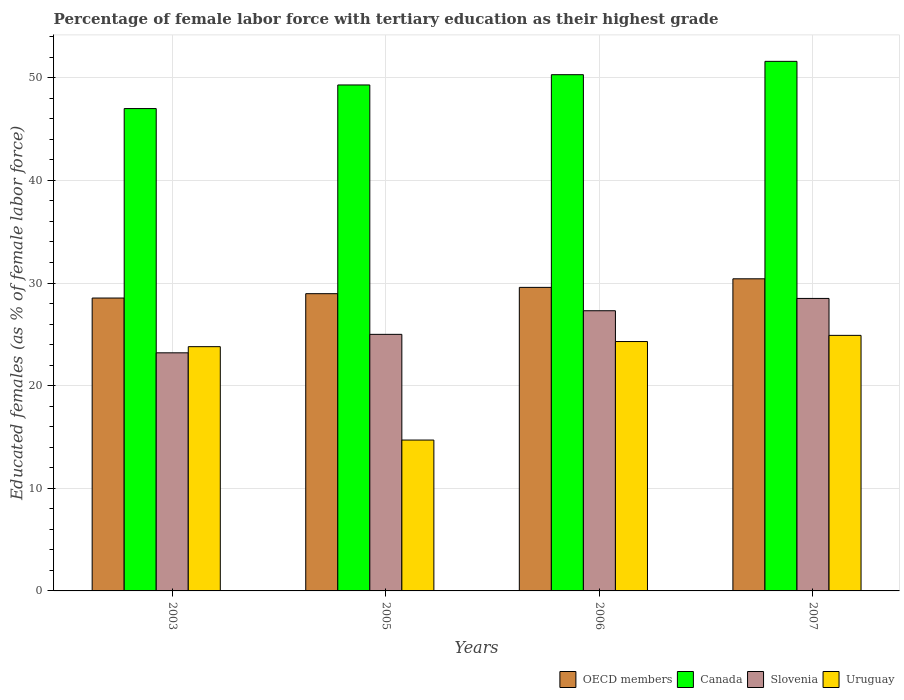How many groups of bars are there?
Provide a short and direct response. 4. Are the number of bars on each tick of the X-axis equal?
Keep it short and to the point. Yes. How many bars are there on the 2nd tick from the right?
Make the answer very short. 4. What is the label of the 1st group of bars from the left?
Provide a short and direct response. 2003. In how many cases, is the number of bars for a given year not equal to the number of legend labels?
Offer a terse response. 0. What is the percentage of female labor force with tertiary education in Uruguay in 2003?
Your answer should be very brief. 23.8. Across all years, what is the maximum percentage of female labor force with tertiary education in OECD members?
Provide a short and direct response. 30.41. Across all years, what is the minimum percentage of female labor force with tertiary education in Slovenia?
Provide a succinct answer. 23.2. In which year was the percentage of female labor force with tertiary education in Canada maximum?
Make the answer very short. 2007. What is the total percentage of female labor force with tertiary education in OECD members in the graph?
Your response must be concise. 117.49. What is the difference between the percentage of female labor force with tertiary education in Slovenia in 2003 and that in 2005?
Provide a short and direct response. -1.8. What is the difference between the percentage of female labor force with tertiary education in OECD members in 2007 and the percentage of female labor force with tertiary education in Slovenia in 2005?
Ensure brevity in your answer.  5.41. What is the average percentage of female labor force with tertiary education in Canada per year?
Offer a terse response. 49.55. In the year 2007, what is the difference between the percentage of female labor force with tertiary education in Uruguay and percentage of female labor force with tertiary education in Slovenia?
Your answer should be compact. -3.6. In how many years, is the percentage of female labor force with tertiary education in Canada greater than 10 %?
Provide a short and direct response. 4. What is the ratio of the percentage of female labor force with tertiary education in Slovenia in 2003 to that in 2007?
Your answer should be very brief. 0.81. Is the percentage of female labor force with tertiary education in Slovenia in 2003 less than that in 2005?
Offer a terse response. Yes. Is the difference between the percentage of female labor force with tertiary education in Uruguay in 2005 and 2007 greater than the difference between the percentage of female labor force with tertiary education in Slovenia in 2005 and 2007?
Provide a short and direct response. No. What is the difference between the highest and the second highest percentage of female labor force with tertiary education in OECD members?
Offer a terse response. 0.84. What is the difference between the highest and the lowest percentage of female labor force with tertiary education in OECD members?
Make the answer very short. 1.87. In how many years, is the percentage of female labor force with tertiary education in Uruguay greater than the average percentage of female labor force with tertiary education in Uruguay taken over all years?
Ensure brevity in your answer.  3. Is the sum of the percentage of female labor force with tertiary education in Uruguay in 2003 and 2007 greater than the maximum percentage of female labor force with tertiary education in Slovenia across all years?
Keep it short and to the point. Yes. Is it the case that in every year, the sum of the percentage of female labor force with tertiary education in Uruguay and percentage of female labor force with tertiary education in Canada is greater than the sum of percentage of female labor force with tertiary education in OECD members and percentage of female labor force with tertiary education in Slovenia?
Your answer should be very brief. Yes. What does the 2nd bar from the right in 2006 represents?
Provide a short and direct response. Slovenia. How many bars are there?
Give a very brief answer. 16. Are all the bars in the graph horizontal?
Ensure brevity in your answer.  No. How many years are there in the graph?
Give a very brief answer. 4. What is the difference between two consecutive major ticks on the Y-axis?
Provide a succinct answer. 10. Does the graph contain any zero values?
Provide a short and direct response. No. Where does the legend appear in the graph?
Offer a very short reply. Bottom right. How many legend labels are there?
Offer a terse response. 4. What is the title of the graph?
Provide a succinct answer. Percentage of female labor force with tertiary education as their highest grade. Does "Other small states" appear as one of the legend labels in the graph?
Offer a terse response. No. What is the label or title of the X-axis?
Keep it short and to the point. Years. What is the label or title of the Y-axis?
Provide a succinct answer. Educated females (as % of female labor force). What is the Educated females (as % of female labor force) in OECD members in 2003?
Your response must be concise. 28.54. What is the Educated females (as % of female labor force) in Canada in 2003?
Offer a terse response. 47. What is the Educated females (as % of female labor force) of Slovenia in 2003?
Offer a terse response. 23.2. What is the Educated females (as % of female labor force) in Uruguay in 2003?
Ensure brevity in your answer.  23.8. What is the Educated females (as % of female labor force) of OECD members in 2005?
Your answer should be compact. 28.96. What is the Educated females (as % of female labor force) in Canada in 2005?
Provide a succinct answer. 49.3. What is the Educated females (as % of female labor force) in Slovenia in 2005?
Give a very brief answer. 25. What is the Educated females (as % of female labor force) of Uruguay in 2005?
Make the answer very short. 14.7. What is the Educated females (as % of female labor force) of OECD members in 2006?
Your response must be concise. 29.58. What is the Educated females (as % of female labor force) in Canada in 2006?
Make the answer very short. 50.3. What is the Educated females (as % of female labor force) in Slovenia in 2006?
Your answer should be compact. 27.3. What is the Educated females (as % of female labor force) in Uruguay in 2006?
Provide a succinct answer. 24.3. What is the Educated females (as % of female labor force) in OECD members in 2007?
Ensure brevity in your answer.  30.41. What is the Educated females (as % of female labor force) of Canada in 2007?
Give a very brief answer. 51.6. What is the Educated females (as % of female labor force) in Uruguay in 2007?
Provide a short and direct response. 24.9. Across all years, what is the maximum Educated females (as % of female labor force) of OECD members?
Your answer should be compact. 30.41. Across all years, what is the maximum Educated females (as % of female labor force) in Canada?
Provide a succinct answer. 51.6. Across all years, what is the maximum Educated females (as % of female labor force) of Slovenia?
Offer a very short reply. 28.5. Across all years, what is the maximum Educated females (as % of female labor force) in Uruguay?
Give a very brief answer. 24.9. Across all years, what is the minimum Educated females (as % of female labor force) of OECD members?
Give a very brief answer. 28.54. Across all years, what is the minimum Educated females (as % of female labor force) of Canada?
Offer a very short reply. 47. Across all years, what is the minimum Educated females (as % of female labor force) of Slovenia?
Make the answer very short. 23.2. Across all years, what is the minimum Educated females (as % of female labor force) in Uruguay?
Your answer should be very brief. 14.7. What is the total Educated females (as % of female labor force) in OECD members in the graph?
Give a very brief answer. 117.49. What is the total Educated females (as % of female labor force) in Canada in the graph?
Make the answer very short. 198.2. What is the total Educated females (as % of female labor force) of Slovenia in the graph?
Make the answer very short. 104. What is the total Educated females (as % of female labor force) in Uruguay in the graph?
Provide a short and direct response. 87.7. What is the difference between the Educated females (as % of female labor force) of OECD members in 2003 and that in 2005?
Provide a short and direct response. -0.42. What is the difference between the Educated females (as % of female labor force) in Canada in 2003 and that in 2005?
Make the answer very short. -2.3. What is the difference between the Educated females (as % of female labor force) of Slovenia in 2003 and that in 2005?
Keep it short and to the point. -1.8. What is the difference between the Educated females (as % of female labor force) of OECD members in 2003 and that in 2006?
Your answer should be compact. -1.04. What is the difference between the Educated females (as % of female labor force) in Canada in 2003 and that in 2006?
Give a very brief answer. -3.3. What is the difference between the Educated females (as % of female labor force) of Uruguay in 2003 and that in 2006?
Your answer should be very brief. -0.5. What is the difference between the Educated females (as % of female labor force) in OECD members in 2003 and that in 2007?
Provide a short and direct response. -1.87. What is the difference between the Educated females (as % of female labor force) in Canada in 2003 and that in 2007?
Offer a very short reply. -4.6. What is the difference between the Educated females (as % of female labor force) of OECD members in 2005 and that in 2006?
Provide a succinct answer. -0.61. What is the difference between the Educated females (as % of female labor force) in Canada in 2005 and that in 2006?
Your response must be concise. -1. What is the difference between the Educated females (as % of female labor force) in Slovenia in 2005 and that in 2006?
Keep it short and to the point. -2.3. What is the difference between the Educated females (as % of female labor force) of OECD members in 2005 and that in 2007?
Provide a succinct answer. -1.45. What is the difference between the Educated females (as % of female labor force) in Canada in 2005 and that in 2007?
Provide a succinct answer. -2.3. What is the difference between the Educated females (as % of female labor force) of Slovenia in 2005 and that in 2007?
Your answer should be very brief. -3.5. What is the difference between the Educated females (as % of female labor force) of OECD members in 2006 and that in 2007?
Give a very brief answer. -0.84. What is the difference between the Educated females (as % of female labor force) of Canada in 2006 and that in 2007?
Make the answer very short. -1.3. What is the difference between the Educated females (as % of female labor force) of Uruguay in 2006 and that in 2007?
Provide a succinct answer. -0.6. What is the difference between the Educated females (as % of female labor force) in OECD members in 2003 and the Educated females (as % of female labor force) in Canada in 2005?
Give a very brief answer. -20.76. What is the difference between the Educated females (as % of female labor force) of OECD members in 2003 and the Educated females (as % of female labor force) of Slovenia in 2005?
Offer a very short reply. 3.54. What is the difference between the Educated females (as % of female labor force) in OECD members in 2003 and the Educated females (as % of female labor force) in Uruguay in 2005?
Ensure brevity in your answer.  13.84. What is the difference between the Educated females (as % of female labor force) of Canada in 2003 and the Educated females (as % of female labor force) of Uruguay in 2005?
Your answer should be compact. 32.3. What is the difference between the Educated females (as % of female labor force) in OECD members in 2003 and the Educated females (as % of female labor force) in Canada in 2006?
Offer a terse response. -21.76. What is the difference between the Educated females (as % of female labor force) in OECD members in 2003 and the Educated females (as % of female labor force) in Slovenia in 2006?
Offer a terse response. 1.24. What is the difference between the Educated females (as % of female labor force) in OECD members in 2003 and the Educated females (as % of female labor force) in Uruguay in 2006?
Keep it short and to the point. 4.24. What is the difference between the Educated females (as % of female labor force) in Canada in 2003 and the Educated females (as % of female labor force) in Slovenia in 2006?
Ensure brevity in your answer.  19.7. What is the difference between the Educated females (as % of female labor force) of Canada in 2003 and the Educated females (as % of female labor force) of Uruguay in 2006?
Offer a terse response. 22.7. What is the difference between the Educated females (as % of female labor force) of Slovenia in 2003 and the Educated females (as % of female labor force) of Uruguay in 2006?
Make the answer very short. -1.1. What is the difference between the Educated females (as % of female labor force) in OECD members in 2003 and the Educated females (as % of female labor force) in Canada in 2007?
Ensure brevity in your answer.  -23.06. What is the difference between the Educated females (as % of female labor force) in OECD members in 2003 and the Educated females (as % of female labor force) in Slovenia in 2007?
Offer a very short reply. 0.04. What is the difference between the Educated females (as % of female labor force) in OECD members in 2003 and the Educated females (as % of female labor force) in Uruguay in 2007?
Provide a short and direct response. 3.64. What is the difference between the Educated females (as % of female labor force) in Canada in 2003 and the Educated females (as % of female labor force) in Slovenia in 2007?
Offer a terse response. 18.5. What is the difference between the Educated females (as % of female labor force) in Canada in 2003 and the Educated females (as % of female labor force) in Uruguay in 2007?
Your answer should be compact. 22.1. What is the difference between the Educated females (as % of female labor force) in OECD members in 2005 and the Educated females (as % of female labor force) in Canada in 2006?
Your answer should be compact. -21.34. What is the difference between the Educated females (as % of female labor force) in OECD members in 2005 and the Educated females (as % of female labor force) in Slovenia in 2006?
Make the answer very short. 1.66. What is the difference between the Educated females (as % of female labor force) of OECD members in 2005 and the Educated females (as % of female labor force) of Uruguay in 2006?
Make the answer very short. 4.66. What is the difference between the Educated females (as % of female labor force) of Slovenia in 2005 and the Educated females (as % of female labor force) of Uruguay in 2006?
Ensure brevity in your answer.  0.7. What is the difference between the Educated females (as % of female labor force) in OECD members in 2005 and the Educated females (as % of female labor force) in Canada in 2007?
Ensure brevity in your answer.  -22.64. What is the difference between the Educated females (as % of female labor force) of OECD members in 2005 and the Educated females (as % of female labor force) of Slovenia in 2007?
Provide a succinct answer. 0.46. What is the difference between the Educated females (as % of female labor force) in OECD members in 2005 and the Educated females (as % of female labor force) in Uruguay in 2007?
Your response must be concise. 4.06. What is the difference between the Educated females (as % of female labor force) of Canada in 2005 and the Educated females (as % of female labor force) of Slovenia in 2007?
Provide a succinct answer. 20.8. What is the difference between the Educated females (as % of female labor force) in Canada in 2005 and the Educated females (as % of female labor force) in Uruguay in 2007?
Ensure brevity in your answer.  24.4. What is the difference between the Educated females (as % of female labor force) of OECD members in 2006 and the Educated females (as % of female labor force) of Canada in 2007?
Provide a short and direct response. -22.02. What is the difference between the Educated females (as % of female labor force) of OECD members in 2006 and the Educated females (as % of female labor force) of Slovenia in 2007?
Keep it short and to the point. 1.08. What is the difference between the Educated females (as % of female labor force) in OECD members in 2006 and the Educated females (as % of female labor force) in Uruguay in 2007?
Offer a very short reply. 4.68. What is the difference between the Educated females (as % of female labor force) of Canada in 2006 and the Educated females (as % of female labor force) of Slovenia in 2007?
Ensure brevity in your answer.  21.8. What is the difference between the Educated females (as % of female labor force) of Canada in 2006 and the Educated females (as % of female labor force) of Uruguay in 2007?
Keep it short and to the point. 25.4. What is the difference between the Educated females (as % of female labor force) of Slovenia in 2006 and the Educated females (as % of female labor force) of Uruguay in 2007?
Offer a terse response. 2.4. What is the average Educated females (as % of female labor force) of OECD members per year?
Offer a very short reply. 29.37. What is the average Educated females (as % of female labor force) in Canada per year?
Offer a very short reply. 49.55. What is the average Educated females (as % of female labor force) of Slovenia per year?
Keep it short and to the point. 26. What is the average Educated females (as % of female labor force) in Uruguay per year?
Offer a very short reply. 21.93. In the year 2003, what is the difference between the Educated females (as % of female labor force) in OECD members and Educated females (as % of female labor force) in Canada?
Make the answer very short. -18.46. In the year 2003, what is the difference between the Educated females (as % of female labor force) of OECD members and Educated females (as % of female labor force) of Slovenia?
Offer a terse response. 5.34. In the year 2003, what is the difference between the Educated females (as % of female labor force) of OECD members and Educated females (as % of female labor force) of Uruguay?
Ensure brevity in your answer.  4.74. In the year 2003, what is the difference between the Educated females (as % of female labor force) of Canada and Educated females (as % of female labor force) of Slovenia?
Make the answer very short. 23.8. In the year 2003, what is the difference between the Educated females (as % of female labor force) in Canada and Educated females (as % of female labor force) in Uruguay?
Make the answer very short. 23.2. In the year 2005, what is the difference between the Educated females (as % of female labor force) of OECD members and Educated females (as % of female labor force) of Canada?
Keep it short and to the point. -20.34. In the year 2005, what is the difference between the Educated females (as % of female labor force) of OECD members and Educated females (as % of female labor force) of Slovenia?
Offer a terse response. 3.96. In the year 2005, what is the difference between the Educated females (as % of female labor force) in OECD members and Educated females (as % of female labor force) in Uruguay?
Make the answer very short. 14.26. In the year 2005, what is the difference between the Educated females (as % of female labor force) in Canada and Educated females (as % of female labor force) in Slovenia?
Ensure brevity in your answer.  24.3. In the year 2005, what is the difference between the Educated females (as % of female labor force) of Canada and Educated females (as % of female labor force) of Uruguay?
Provide a short and direct response. 34.6. In the year 2006, what is the difference between the Educated females (as % of female labor force) in OECD members and Educated females (as % of female labor force) in Canada?
Make the answer very short. -20.72. In the year 2006, what is the difference between the Educated females (as % of female labor force) in OECD members and Educated females (as % of female labor force) in Slovenia?
Ensure brevity in your answer.  2.28. In the year 2006, what is the difference between the Educated females (as % of female labor force) of OECD members and Educated females (as % of female labor force) of Uruguay?
Provide a succinct answer. 5.28. In the year 2006, what is the difference between the Educated females (as % of female labor force) in Canada and Educated females (as % of female labor force) in Uruguay?
Offer a very short reply. 26. In the year 2006, what is the difference between the Educated females (as % of female labor force) of Slovenia and Educated females (as % of female labor force) of Uruguay?
Provide a short and direct response. 3. In the year 2007, what is the difference between the Educated females (as % of female labor force) in OECD members and Educated females (as % of female labor force) in Canada?
Provide a succinct answer. -21.19. In the year 2007, what is the difference between the Educated females (as % of female labor force) in OECD members and Educated females (as % of female labor force) in Slovenia?
Offer a very short reply. 1.91. In the year 2007, what is the difference between the Educated females (as % of female labor force) in OECD members and Educated females (as % of female labor force) in Uruguay?
Provide a succinct answer. 5.51. In the year 2007, what is the difference between the Educated females (as % of female labor force) in Canada and Educated females (as % of female labor force) in Slovenia?
Keep it short and to the point. 23.1. In the year 2007, what is the difference between the Educated females (as % of female labor force) of Canada and Educated females (as % of female labor force) of Uruguay?
Ensure brevity in your answer.  26.7. In the year 2007, what is the difference between the Educated females (as % of female labor force) of Slovenia and Educated females (as % of female labor force) of Uruguay?
Ensure brevity in your answer.  3.6. What is the ratio of the Educated females (as % of female labor force) in Canada in 2003 to that in 2005?
Provide a short and direct response. 0.95. What is the ratio of the Educated females (as % of female labor force) of Slovenia in 2003 to that in 2005?
Your answer should be compact. 0.93. What is the ratio of the Educated females (as % of female labor force) in Uruguay in 2003 to that in 2005?
Your answer should be compact. 1.62. What is the ratio of the Educated females (as % of female labor force) in OECD members in 2003 to that in 2006?
Your response must be concise. 0.96. What is the ratio of the Educated females (as % of female labor force) of Canada in 2003 to that in 2006?
Ensure brevity in your answer.  0.93. What is the ratio of the Educated females (as % of female labor force) in Slovenia in 2003 to that in 2006?
Offer a very short reply. 0.85. What is the ratio of the Educated females (as % of female labor force) in Uruguay in 2003 to that in 2006?
Your response must be concise. 0.98. What is the ratio of the Educated females (as % of female labor force) of OECD members in 2003 to that in 2007?
Ensure brevity in your answer.  0.94. What is the ratio of the Educated females (as % of female labor force) in Canada in 2003 to that in 2007?
Give a very brief answer. 0.91. What is the ratio of the Educated females (as % of female labor force) in Slovenia in 2003 to that in 2007?
Make the answer very short. 0.81. What is the ratio of the Educated females (as % of female labor force) of Uruguay in 2003 to that in 2007?
Your response must be concise. 0.96. What is the ratio of the Educated females (as % of female labor force) of OECD members in 2005 to that in 2006?
Your answer should be very brief. 0.98. What is the ratio of the Educated females (as % of female labor force) of Canada in 2005 to that in 2006?
Make the answer very short. 0.98. What is the ratio of the Educated females (as % of female labor force) in Slovenia in 2005 to that in 2006?
Keep it short and to the point. 0.92. What is the ratio of the Educated females (as % of female labor force) of Uruguay in 2005 to that in 2006?
Provide a short and direct response. 0.6. What is the ratio of the Educated females (as % of female labor force) of OECD members in 2005 to that in 2007?
Offer a very short reply. 0.95. What is the ratio of the Educated females (as % of female labor force) in Canada in 2005 to that in 2007?
Your answer should be very brief. 0.96. What is the ratio of the Educated females (as % of female labor force) in Slovenia in 2005 to that in 2007?
Offer a terse response. 0.88. What is the ratio of the Educated females (as % of female labor force) of Uruguay in 2005 to that in 2007?
Ensure brevity in your answer.  0.59. What is the ratio of the Educated females (as % of female labor force) of OECD members in 2006 to that in 2007?
Provide a short and direct response. 0.97. What is the ratio of the Educated females (as % of female labor force) in Canada in 2006 to that in 2007?
Your response must be concise. 0.97. What is the ratio of the Educated females (as % of female labor force) of Slovenia in 2006 to that in 2007?
Offer a terse response. 0.96. What is the ratio of the Educated females (as % of female labor force) of Uruguay in 2006 to that in 2007?
Offer a very short reply. 0.98. What is the difference between the highest and the second highest Educated females (as % of female labor force) of OECD members?
Provide a succinct answer. 0.84. What is the difference between the highest and the lowest Educated females (as % of female labor force) in OECD members?
Offer a very short reply. 1.87. What is the difference between the highest and the lowest Educated females (as % of female labor force) of Canada?
Your response must be concise. 4.6. What is the difference between the highest and the lowest Educated females (as % of female labor force) of Uruguay?
Ensure brevity in your answer.  10.2. 